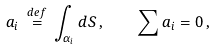Convert formula to latex. <formula><loc_0><loc_0><loc_500><loc_500>a _ { i } \, \overset { d e f } = \, \int _ { \alpha _ { i } } d S \, , \quad \sum a _ { i } = 0 \, ,</formula> 